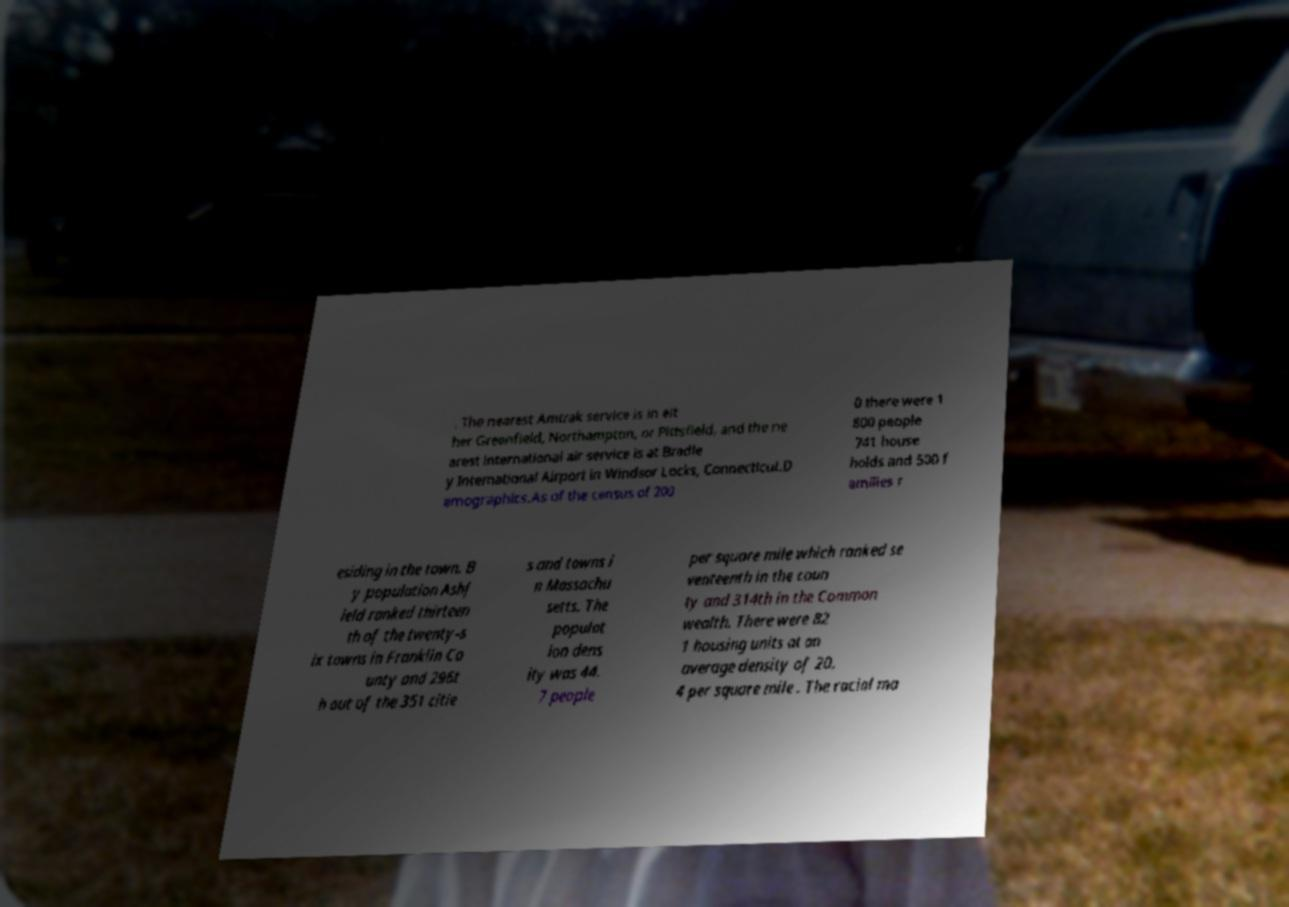Please identify and transcribe the text found in this image. . The nearest Amtrak service is in eit her Greenfield, Northampton, or Pittsfield, and the ne arest international air service is at Bradle y International Airport in Windsor Locks, Connecticut.D emographics.As of the census of 200 0 there were 1 800 people 741 house holds and 500 f amilies r esiding in the town. B y population Ashf ield ranked thirteen th of the twenty-s ix towns in Franklin Co unty and 296t h out of the 351 citie s and towns i n Massachu setts. The populat ion dens ity was 44. 7 people per square mile which ranked se venteenth in the coun ty and 314th in the Common wealth. There were 82 1 housing units at an average density of 20. 4 per square mile . The racial ma 